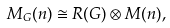Convert formula to latex. <formula><loc_0><loc_0><loc_500><loc_500>M _ { G } ( n ) \cong R ( G ) \otimes M ( n ) ,</formula> 